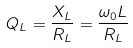Convert formula to latex. <formula><loc_0><loc_0><loc_500><loc_500>Q _ { L } = \frac { X _ { L } } { R _ { L } } = \frac { \omega _ { 0 } L } { R _ { L } }</formula> 